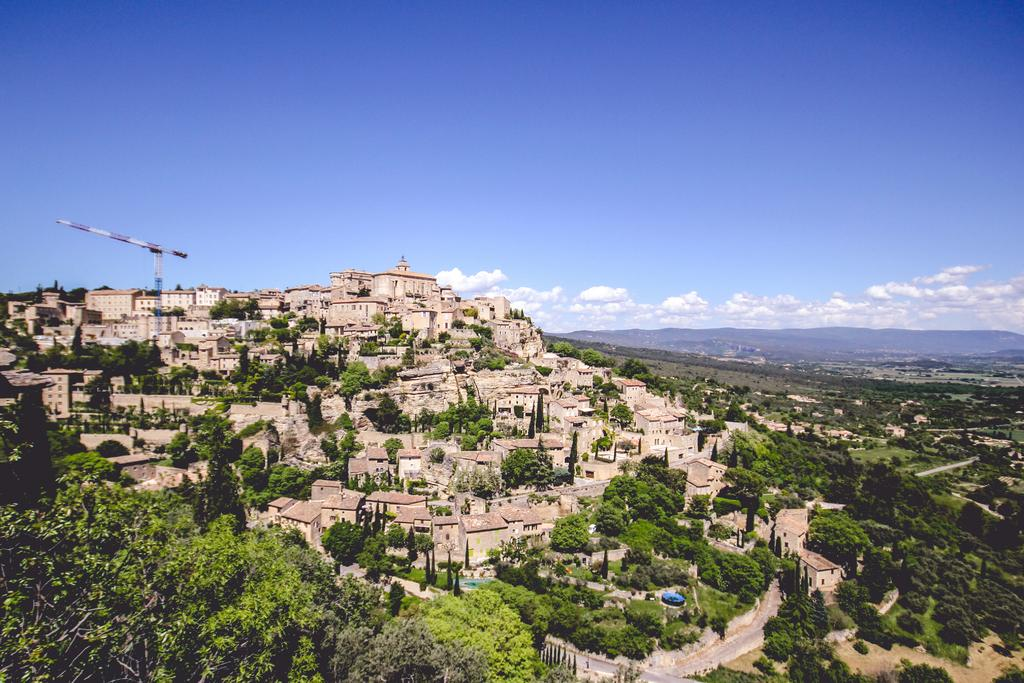What type of structures can be seen in the image? There are many houses in the image. What other natural elements are present in the image? There are trees in the image. What can be seen in the foreground of the image? There is a road visible in the image. What is visible in the background of the image? There are mountains and clouds in the background of the image, and the sky is blue. What type of insurance policy is being advertised on the banana in the image? There is no banana present in the image, and therefore no insurance policy can be advertised on it. 